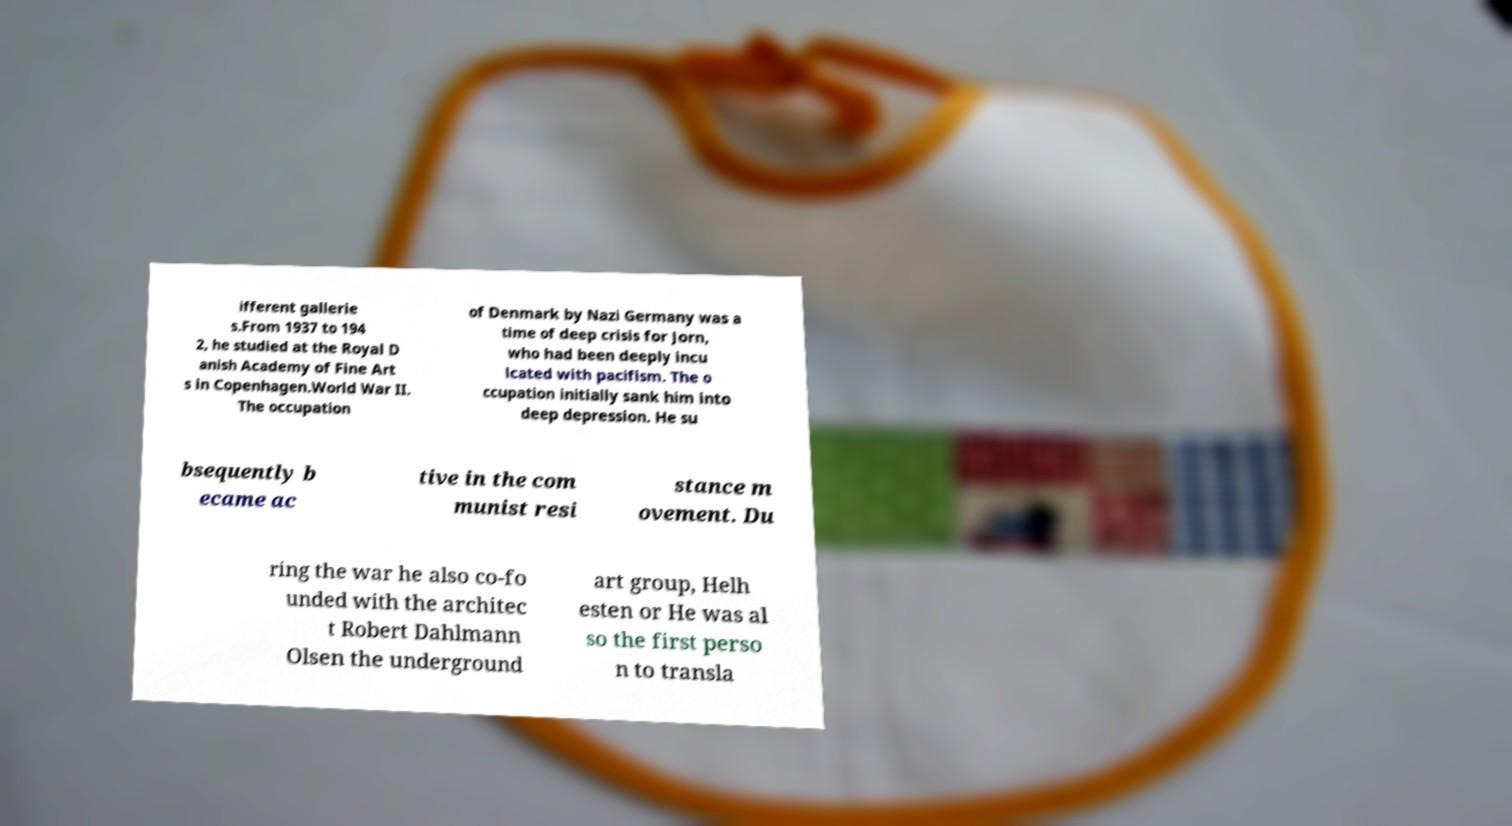There's text embedded in this image that I need extracted. Can you transcribe it verbatim? ifferent gallerie s.From 1937 to 194 2, he studied at the Royal D anish Academy of Fine Art s in Copenhagen.World War II. The occupation of Denmark by Nazi Germany was a time of deep crisis for Jorn, who had been deeply incu lcated with pacifism. The o ccupation initially sank him into deep depression. He su bsequently b ecame ac tive in the com munist resi stance m ovement. Du ring the war he also co-fo unded with the architec t Robert Dahlmann Olsen the underground art group, Helh esten or He was al so the first perso n to transla 